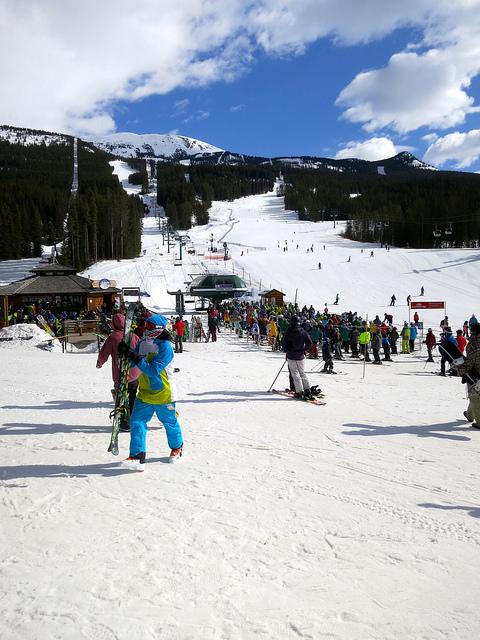Are the people in the photo bowling?
Keep it brief. No. Is it snowing?
Answer briefly. No. How is the sky?
Short answer required. Cloudy. 